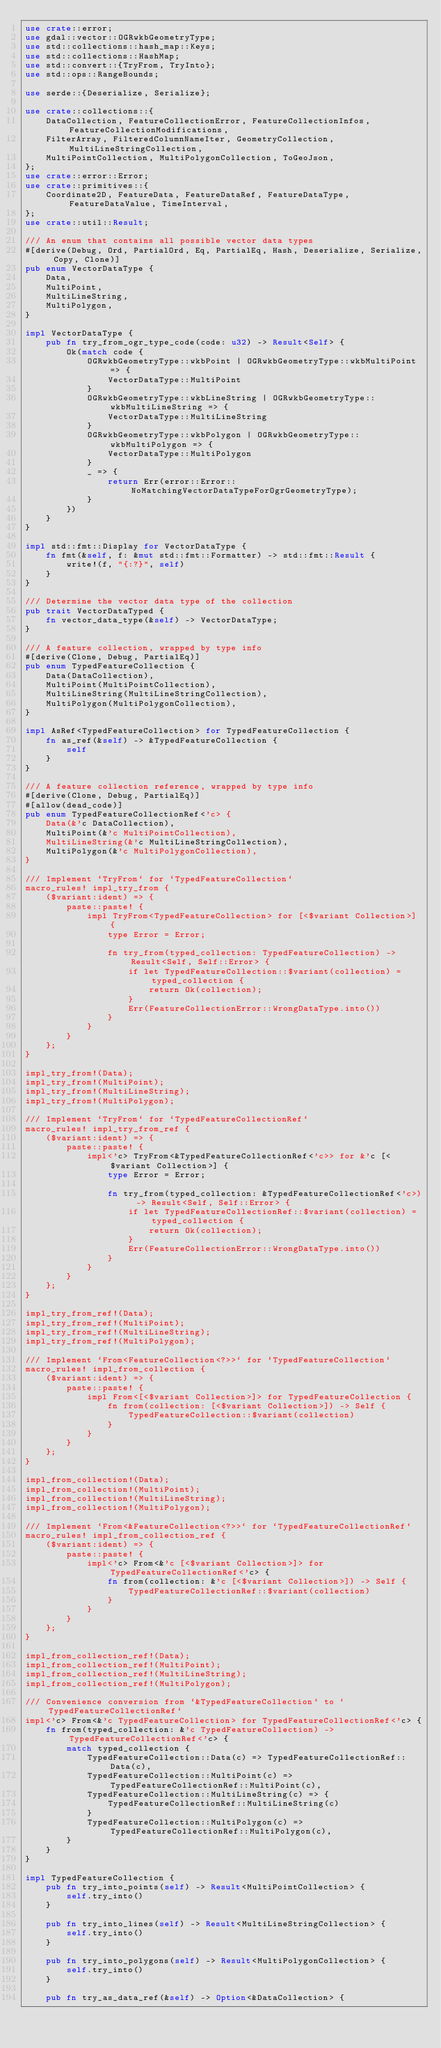<code> <loc_0><loc_0><loc_500><loc_500><_Rust_>use crate::error;
use gdal::vector::OGRwkbGeometryType;
use std::collections::hash_map::Keys;
use std::collections::HashMap;
use std::convert::{TryFrom, TryInto};
use std::ops::RangeBounds;

use serde::{Deserialize, Serialize};

use crate::collections::{
    DataCollection, FeatureCollectionError, FeatureCollectionInfos, FeatureCollectionModifications,
    FilterArray, FilteredColumnNameIter, GeometryCollection, MultiLineStringCollection,
    MultiPointCollection, MultiPolygonCollection, ToGeoJson,
};
use crate::error::Error;
use crate::primitives::{
    Coordinate2D, FeatureData, FeatureDataRef, FeatureDataType, FeatureDataValue, TimeInterval,
};
use crate::util::Result;

/// An enum that contains all possible vector data types
#[derive(Debug, Ord, PartialOrd, Eq, PartialEq, Hash, Deserialize, Serialize, Copy, Clone)]
pub enum VectorDataType {
    Data,
    MultiPoint,
    MultiLineString,
    MultiPolygon,
}

impl VectorDataType {
    pub fn try_from_ogr_type_code(code: u32) -> Result<Self> {
        Ok(match code {
            OGRwkbGeometryType::wkbPoint | OGRwkbGeometryType::wkbMultiPoint => {
                VectorDataType::MultiPoint
            }
            OGRwkbGeometryType::wkbLineString | OGRwkbGeometryType::wkbMultiLineString => {
                VectorDataType::MultiLineString
            }
            OGRwkbGeometryType::wkbPolygon | OGRwkbGeometryType::wkbMultiPolygon => {
                VectorDataType::MultiPolygon
            }
            _ => {
                return Err(error::Error::NoMatchingVectorDataTypeForOgrGeometryType);
            }
        })
    }
}

impl std::fmt::Display for VectorDataType {
    fn fmt(&self, f: &mut std::fmt::Formatter) -> std::fmt::Result {
        write!(f, "{:?}", self)
    }
}

/// Determine the vector data type of the collection
pub trait VectorDataTyped {
    fn vector_data_type(&self) -> VectorDataType;
}

/// A feature collection, wrapped by type info
#[derive(Clone, Debug, PartialEq)]
pub enum TypedFeatureCollection {
    Data(DataCollection),
    MultiPoint(MultiPointCollection),
    MultiLineString(MultiLineStringCollection),
    MultiPolygon(MultiPolygonCollection),
}

impl AsRef<TypedFeatureCollection> for TypedFeatureCollection {
    fn as_ref(&self) -> &TypedFeatureCollection {
        self
    }
}

/// A feature collection reference, wrapped by type info
#[derive(Clone, Debug, PartialEq)]
#[allow(dead_code)]
pub enum TypedFeatureCollectionRef<'c> {
    Data(&'c DataCollection),
    MultiPoint(&'c MultiPointCollection),
    MultiLineString(&'c MultiLineStringCollection),
    MultiPolygon(&'c MultiPolygonCollection),
}

/// Implement `TryFrom` for `TypedFeatureCollection`
macro_rules! impl_try_from {
    ($variant:ident) => {
        paste::paste! {
            impl TryFrom<TypedFeatureCollection> for [<$variant Collection>] {
                type Error = Error;

                fn try_from(typed_collection: TypedFeatureCollection) -> Result<Self, Self::Error> {
                    if let TypedFeatureCollection::$variant(collection) = typed_collection {
                        return Ok(collection);
                    }
                    Err(FeatureCollectionError::WrongDataType.into())
                }
            }
        }
    };
}

impl_try_from!(Data);
impl_try_from!(MultiPoint);
impl_try_from!(MultiLineString);
impl_try_from!(MultiPolygon);

/// Implement `TryFrom` for `TypedFeatureCollectionRef`
macro_rules! impl_try_from_ref {
    ($variant:ident) => {
        paste::paste! {
            impl<'c> TryFrom<&TypedFeatureCollectionRef<'c>> for &'c [<$variant Collection>] {
                type Error = Error;

                fn try_from(typed_collection: &TypedFeatureCollectionRef<'c>) -> Result<Self, Self::Error> {
                    if let TypedFeatureCollectionRef::$variant(collection) = typed_collection {
                        return Ok(collection);
                    }
                    Err(FeatureCollectionError::WrongDataType.into())
                }
            }
        }
    };
}

impl_try_from_ref!(Data);
impl_try_from_ref!(MultiPoint);
impl_try_from_ref!(MultiLineString);
impl_try_from_ref!(MultiPolygon);

/// Implement `From<FeatureCollection<?>>` for `TypedFeatureCollection`
macro_rules! impl_from_collection {
    ($variant:ident) => {
        paste::paste! {
            impl From<[<$variant Collection>]> for TypedFeatureCollection {
                fn from(collection: [<$variant Collection>]) -> Self {
                    TypedFeatureCollection::$variant(collection)
                }
            }
        }
    };
}

impl_from_collection!(Data);
impl_from_collection!(MultiPoint);
impl_from_collection!(MultiLineString);
impl_from_collection!(MultiPolygon);

/// Implement `From<&FeatureCollection<?>>` for `TypedFeatureCollectionRef`
macro_rules! impl_from_collection_ref {
    ($variant:ident) => {
        paste::paste! {
            impl<'c> From<&'c [<$variant Collection>]> for TypedFeatureCollectionRef<'c> {
                fn from(collection: &'c [<$variant Collection>]) -> Self {
                    TypedFeatureCollectionRef::$variant(collection)
                }
            }
        }
    };
}

impl_from_collection_ref!(Data);
impl_from_collection_ref!(MultiPoint);
impl_from_collection_ref!(MultiLineString);
impl_from_collection_ref!(MultiPolygon);

/// Convenience conversion from `&TypedFeatureCollection` to `TypedFeatureCollectionRef`
impl<'c> From<&'c TypedFeatureCollection> for TypedFeatureCollectionRef<'c> {
    fn from(typed_collection: &'c TypedFeatureCollection) -> TypedFeatureCollectionRef<'c> {
        match typed_collection {
            TypedFeatureCollection::Data(c) => TypedFeatureCollectionRef::Data(c),
            TypedFeatureCollection::MultiPoint(c) => TypedFeatureCollectionRef::MultiPoint(c),
            TypedFeatureCollection::MultiLineString(c) => {
                TypedFeatureCollectionRef::MultiLineString(c)
            }
            TypedFeatureCollection::MultiPolygon(c) => TypedFeatureCollectionRef::MultiPolygon(c),
        }
    }
}

impl TypedFeatureCollection {
    pub fn try_into_points(self) -> Result<MultiPointCollection> {
        self.try_into()
    }

    pub fn try_into_lines(self) -> Result<MultiLineStringCollection> {
        self.try_into()
    }

    pub fn try_into_polygons(self) -> Result<MultiPolygonCollection> {
        self.try_into()
    }

    pub fn try_as_data_ref(&self) -> Option<&DataCollection> {</code> 